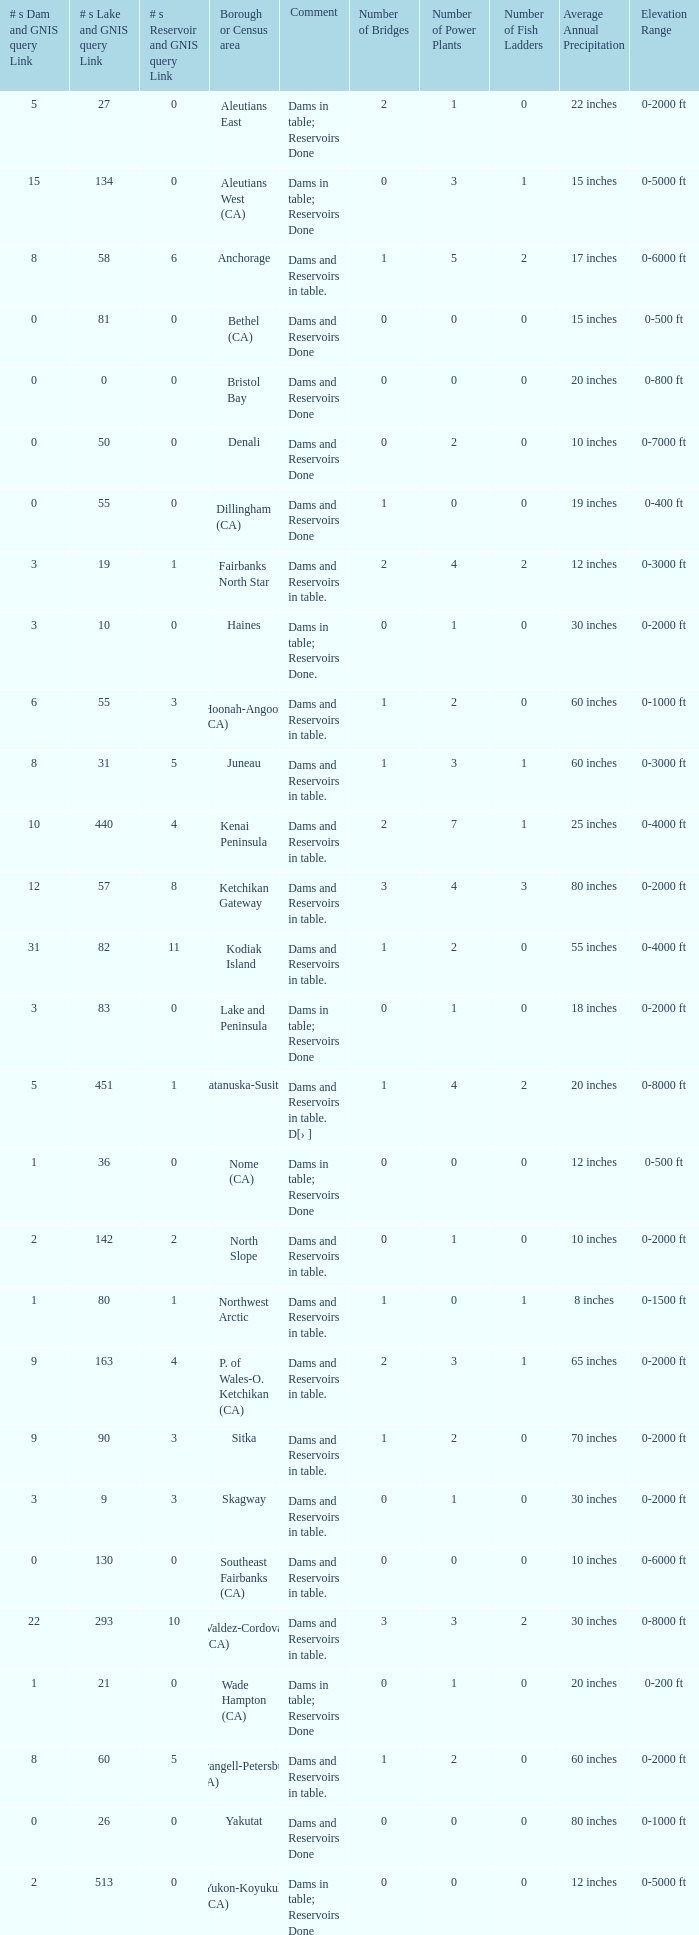Name the minimum number of reservoir for gnis query link where numbers lake gnis query link being 60 5.0. 